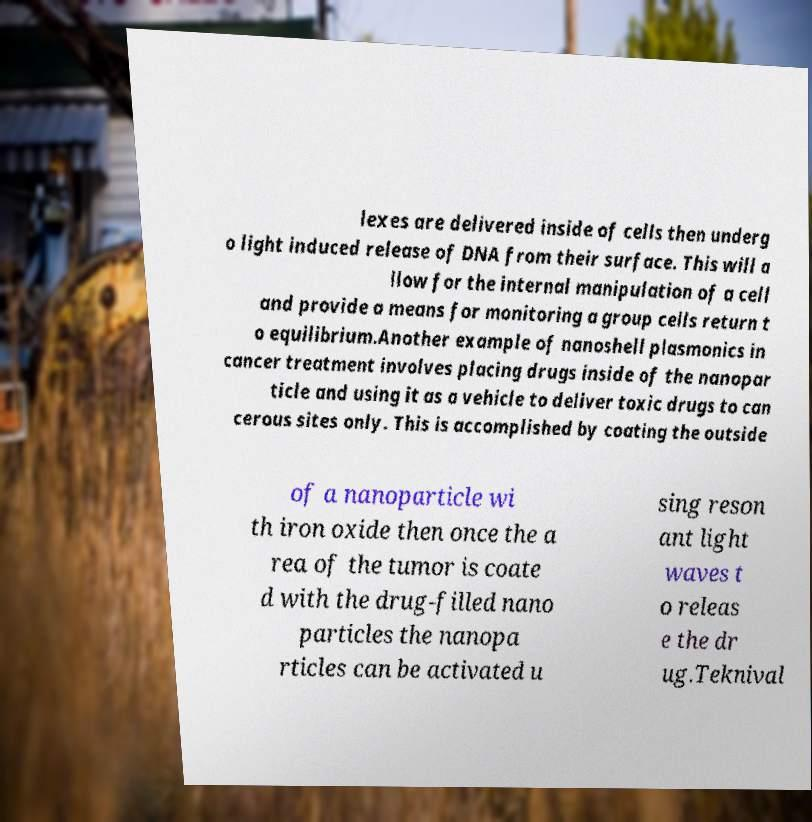Please read and relay the text visible in this image. What does it say? lexes are delivered inside of cells then underg o light induced release of DNA from their surface. This will a llow for the internal manipulation of a cell and provide a means for monitoring a group cells return t o equilibrium.Another example of nanoshell plasmonics in cancer treatment involves placing drugs inside of the nanopar ticle and using it as a vehicle to deliver toxic drugs to can cerous sites only. This is accomplished by coating the outside of a nanoparticle wi th iron oxide then once the a rea of the tumor is coate d with the drug-filled nano particles the nanopa rticles can be activated u sing reson ant light waves t o releas e the dr ug.Teknival 